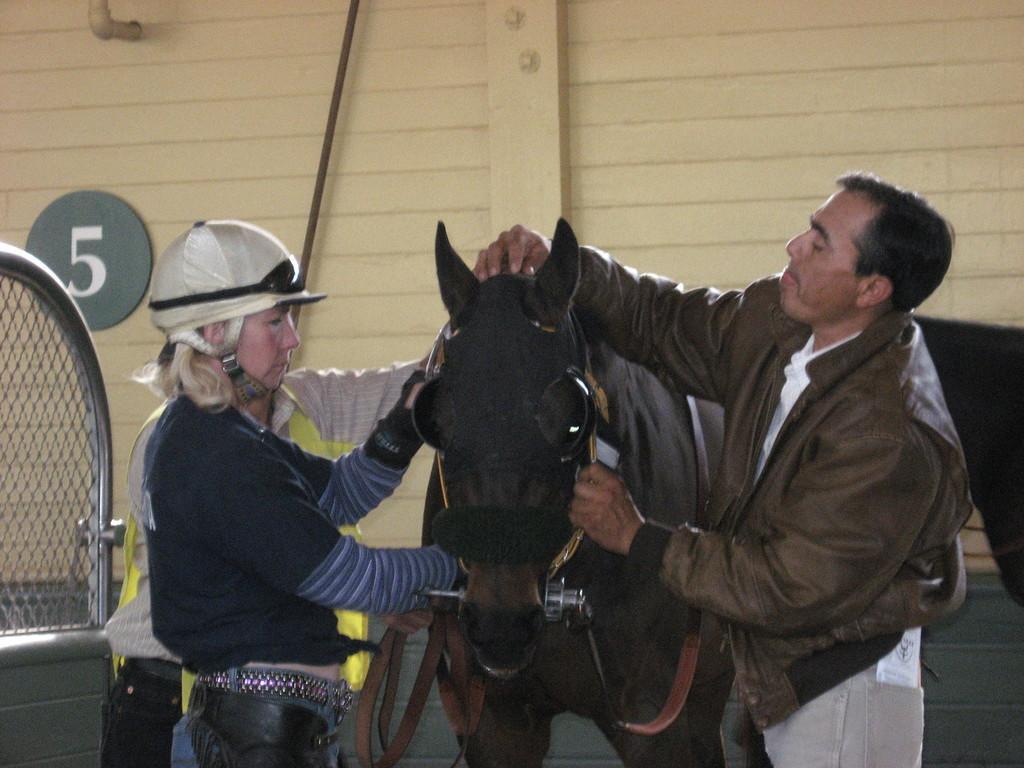Describe this image in one or two sentences. As we can see in the image there are few people in the front, fence, black color horse, wall and a pipe. 